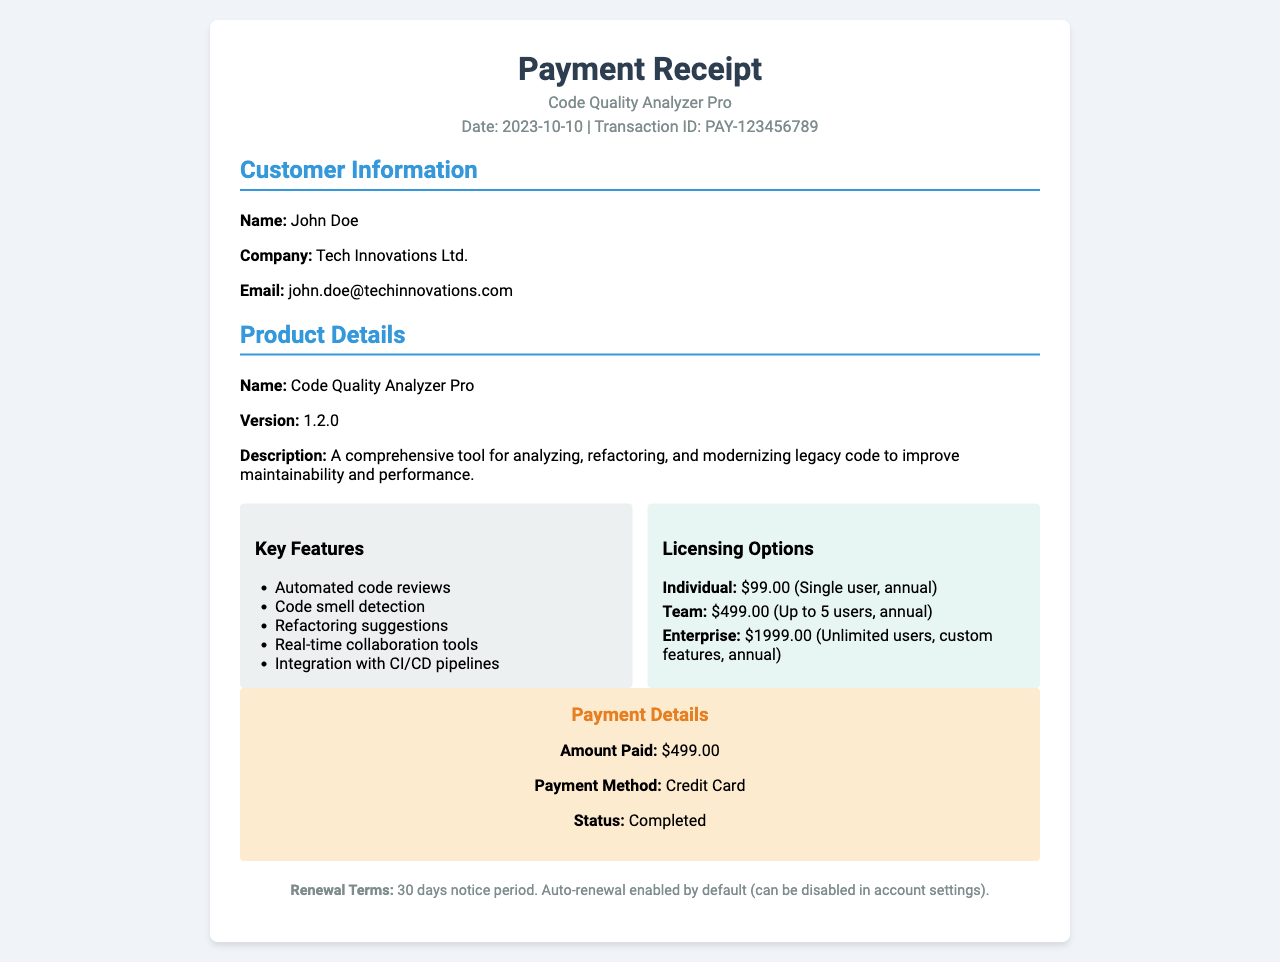What is the product name? The product name is stated in the Product Details section of the document.
Answer: Code Quality Analyzer Pro What is the version number? The version number is found in the Product Details section of the document.
Answer: 1.2.0 What is the total amount paid? The total amount is listed in the Payment Details section of the document.
Answer: $499.00 How many key features are listed? The number of features can be counted from the Key Features section of the document.
Answer: 5 What is the licensing option for teams? The licensing options are detailed in the Licensing Options section of the document.
Answer: $499.00 (Up to 5 users, annual) What is the renewal notice period? The renewal terms are specified in the Renewal section of the document.
Answer: 30 days notice period What payment method was used? The payment method is mentioned in the Payment Details section of the document.
Answer: Credit Card Is auto-renewal enabled by default? The renewal terms state whether auto-renewal is enabled or not.
Answer: Yes What is the customer's email address? The customer's email is listed in the Customer Information section of the document.
Answer: john.doe@techinnovations.com What company does the customer represent? The customer's company is indicated in the Customer Information section of the document.
Answer: Tech Innovations Ltd 